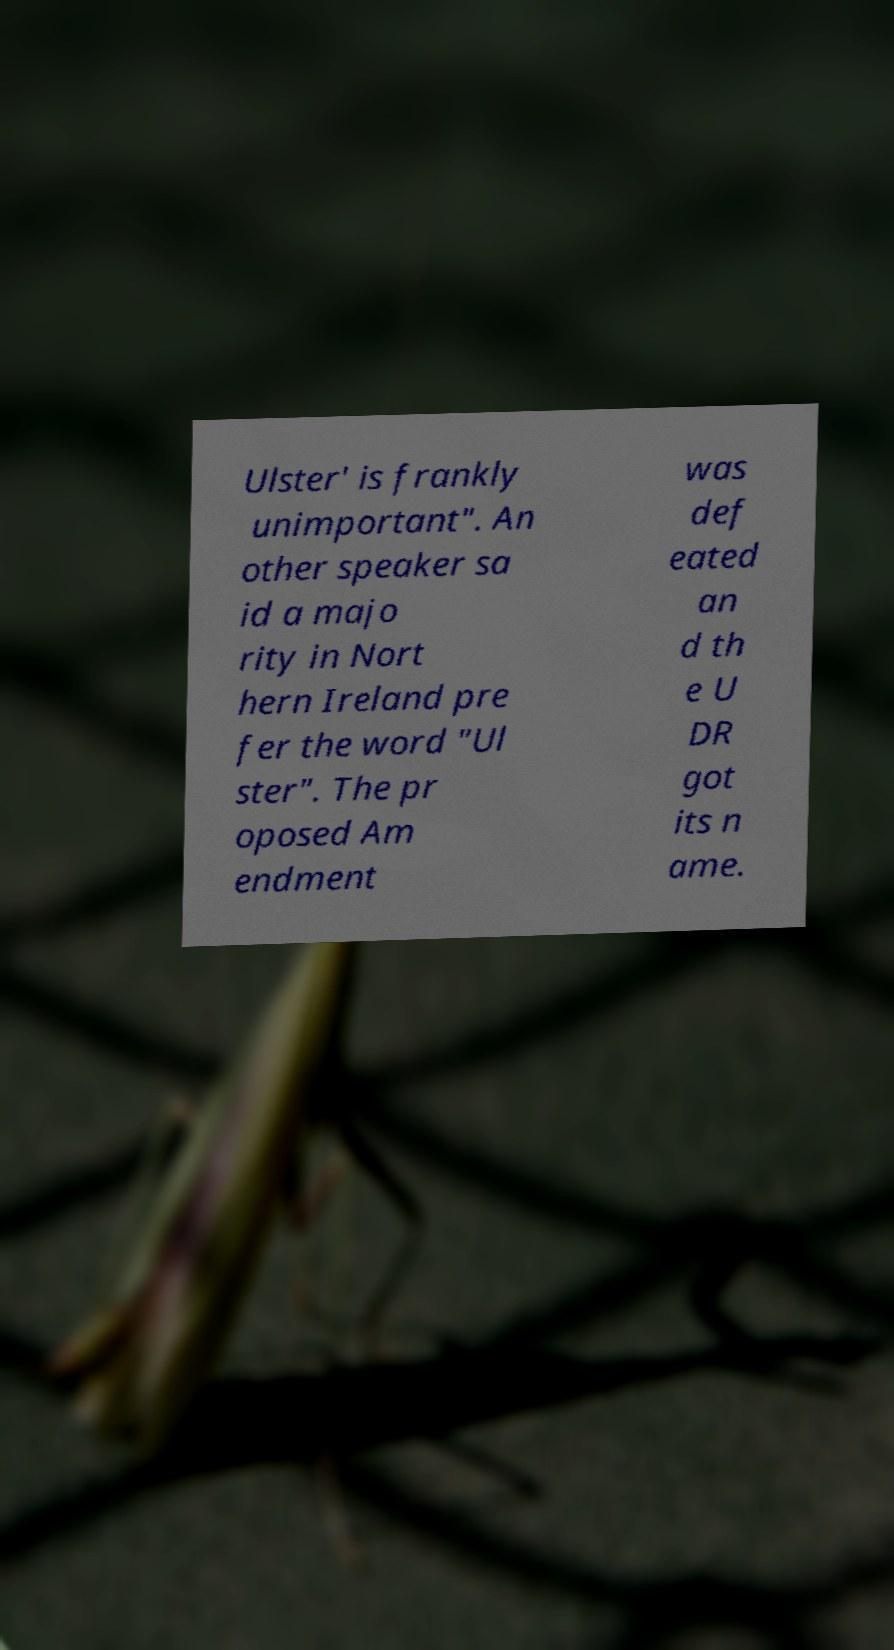I need the written content from this picture converted into text. Can you do that? Ulster' is frankly unimportant". An other speaker sa id a majo rity in Nort hern Ireland pre fer the word "Ul ster". The pr oposed Am endment was def eated an d th e U DR got its n ame. 